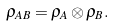Convert formula to latex. <formula><loc_0><loc_0><loc_500><loc_500>\rho _ { A B } = \rho _ { A } \otimes \rho _ { B } .</formula> 